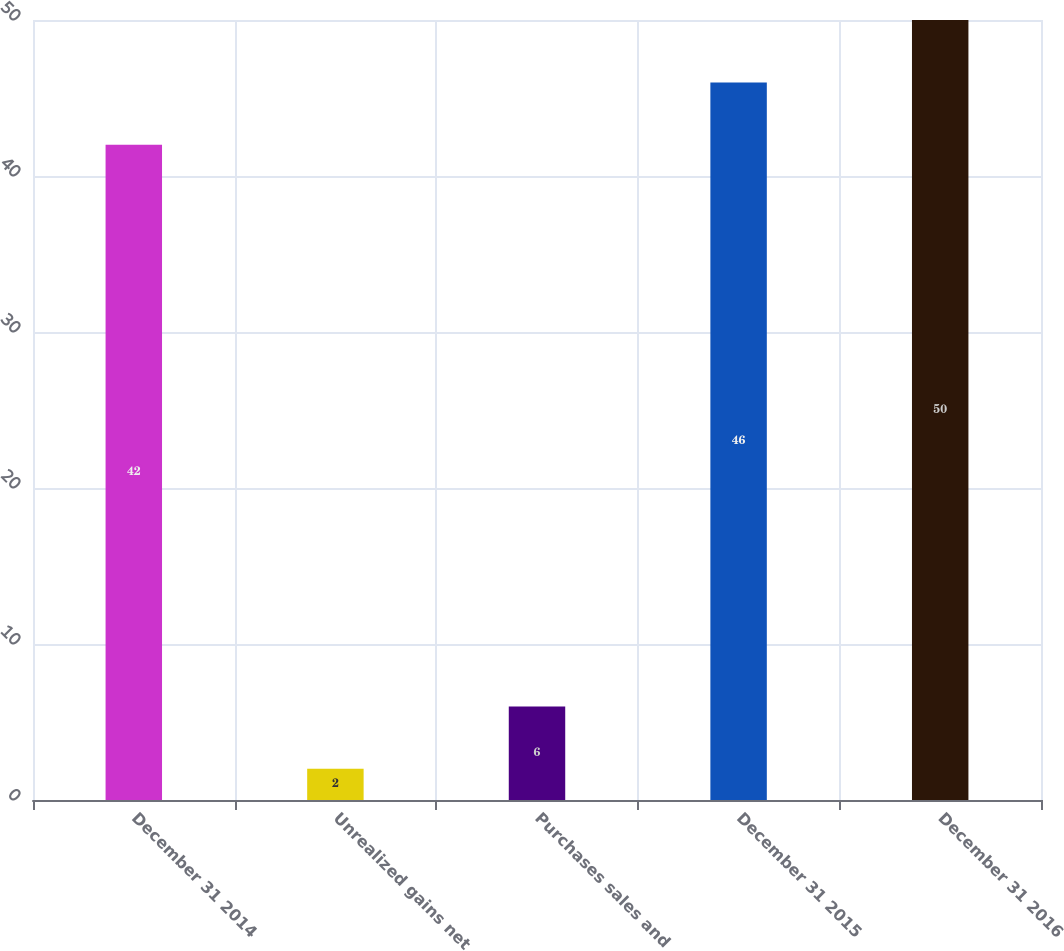Convert chart to OTSL. <chart><loc_0><loc_0><loc_500><loc_500><bar_chart><fcel>December 31 2014<fcel>Unrealized gains net<fcel>Purchases sales and<fcel>December 31 2015<fcel>December 31 2016<nl><fcel>42<fcel>2<fcel>6<fcel>46<fcel>50<nl></chart> 